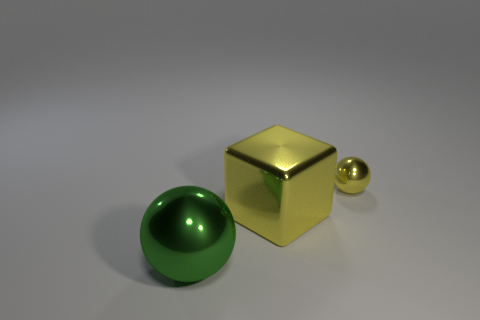Add 1 purple matte spheres. How many objects exist? 4 Subtract all balls. How many objects are left? 1 Add 2 small spheres. How many small spheres are left? 3 Add 2 yellow metal things. How many yellow metal things exist? 4 Subtract 0 green blocks. How many objects are left? 3 Subtract all gray rubber cylinders. Subtract all spheres. How many objects are left? 1 